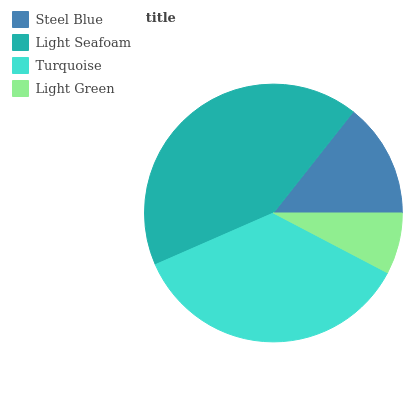Is Light Green the minimum?
Answer yes or no. Yes. Is Light Seafoam the maximum?
Answer yes or no. Yes. Is Turquoise the minimum?
Answer yes or no. No. Is Turquoise the maximum?
Answer yes or no. No. Is Light Seafoam greater than Turquoise?
Answer yes or no. Yes. Is Turquoise less than Light Seafoam?
Answer yes or no. Yes. Is Turquoise greater than Light Seafoam?
Answer yes or no. No. Is Light Seafoam less than Turquoise?
Answer yes or no. No. Is Turquoise the high median?
Answer yes or no. Yes. Is Steel Blue the low median?
Answer yes or no. Yes. Is Light Green the high median?
Answer yes or no. No. Is Light Green the low median?
Answer yes or no. No. 